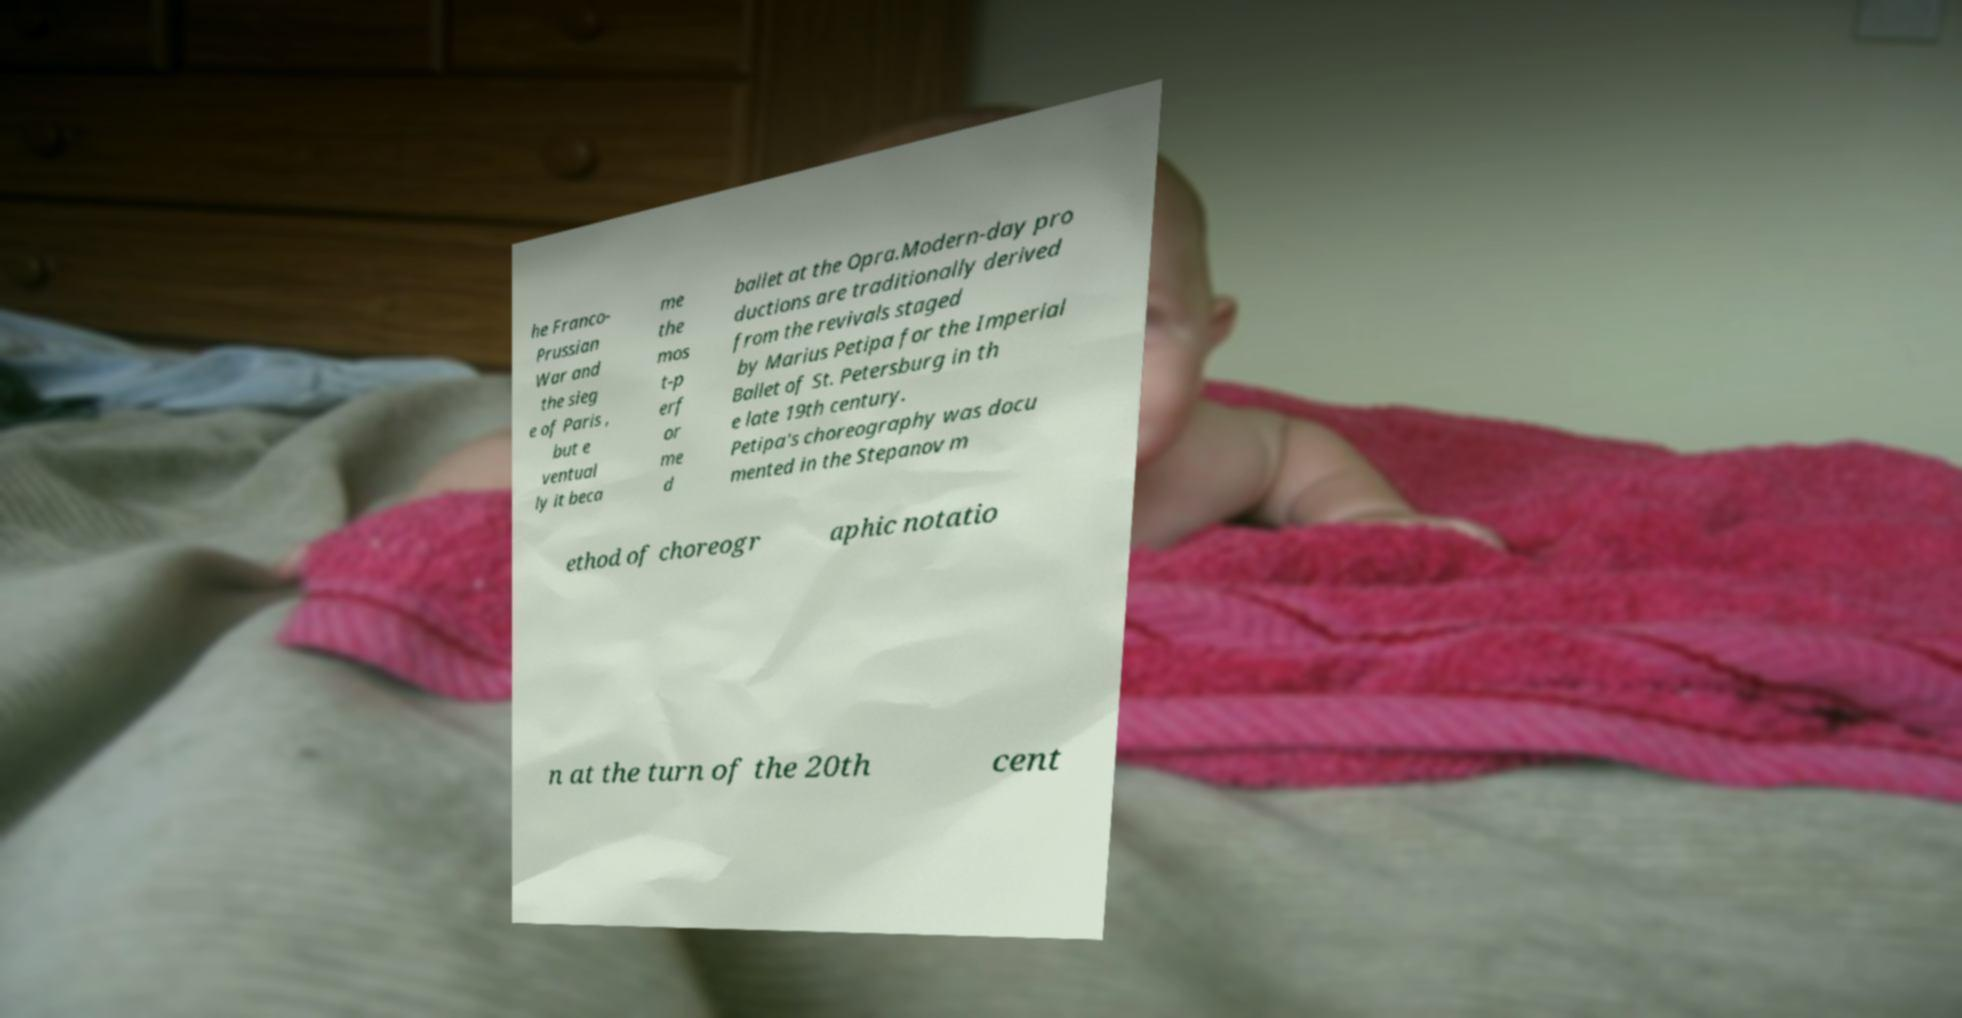Please identify and transcribe the text found in this image. he Franco- Prussian War and the sieg e of Paris , but e ventual ly it beca me the mos t-p erf or me d ballet at the Opra.Modern-day pro ductions are traditionally derived from the revivals staged by Marius Petipa for the Imperial Ballet of St. Petersburg in th e late 19th century. Petipa's choreography was docu mented in the Stepanov m ethod of choreogr aphic notatio n at the turn of the 20th cent 